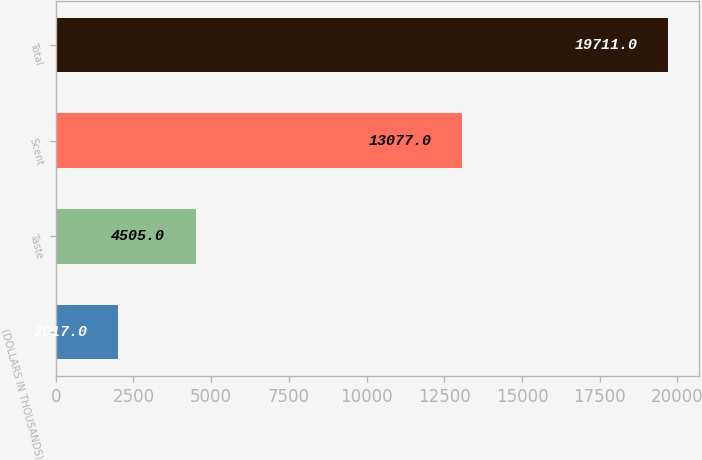Convert chart. <chart><loc_0><loc_0><loc_500><loc_500><bar_chart><fcel>(DOLLARS IN THOUSANDS)<fcel>Taste<fcel>Scent<fcel>Total<nl><fcel>2017<fcel>4505<fcel>13077<fcel>19711<nl></chart> 